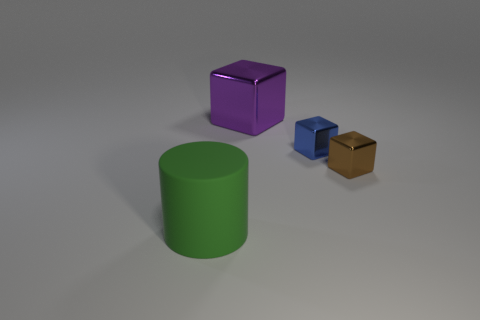Add 2 yellow metal blocks. How many objects exist? 6 Subtract all cylinders. How many objects are left? 3 Add 3 green matte things. How many green matte things exist? 4 Subtract 0 red cylinders. How many objects are left? 4 Subtract all cyan objects. Subtract all purple objects. How many objects are left? 3 Add 3 large green matte cylinders. How many large green matte cylinders are left? 4 